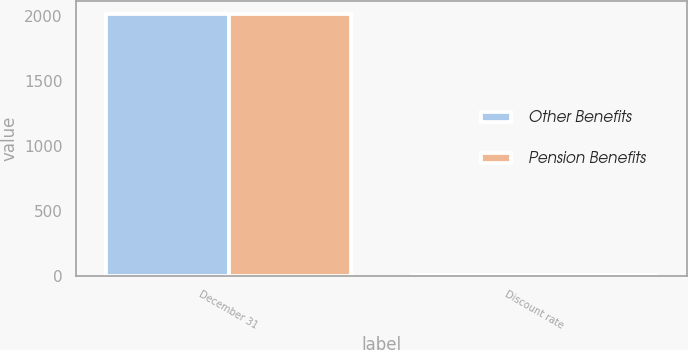Convert chart to OTSL. <chart><loc_0><loc_0><loc_500><loc_500><stacked_bar_chart><ecel><fcel>December 31<fcel>Discount rate<nl><fcel>Other Benefits<fcel>2017<fcel>3.4<nl><fcel>Pension Benefits<fcel>2017<fcel>3.5<nl></chart> 